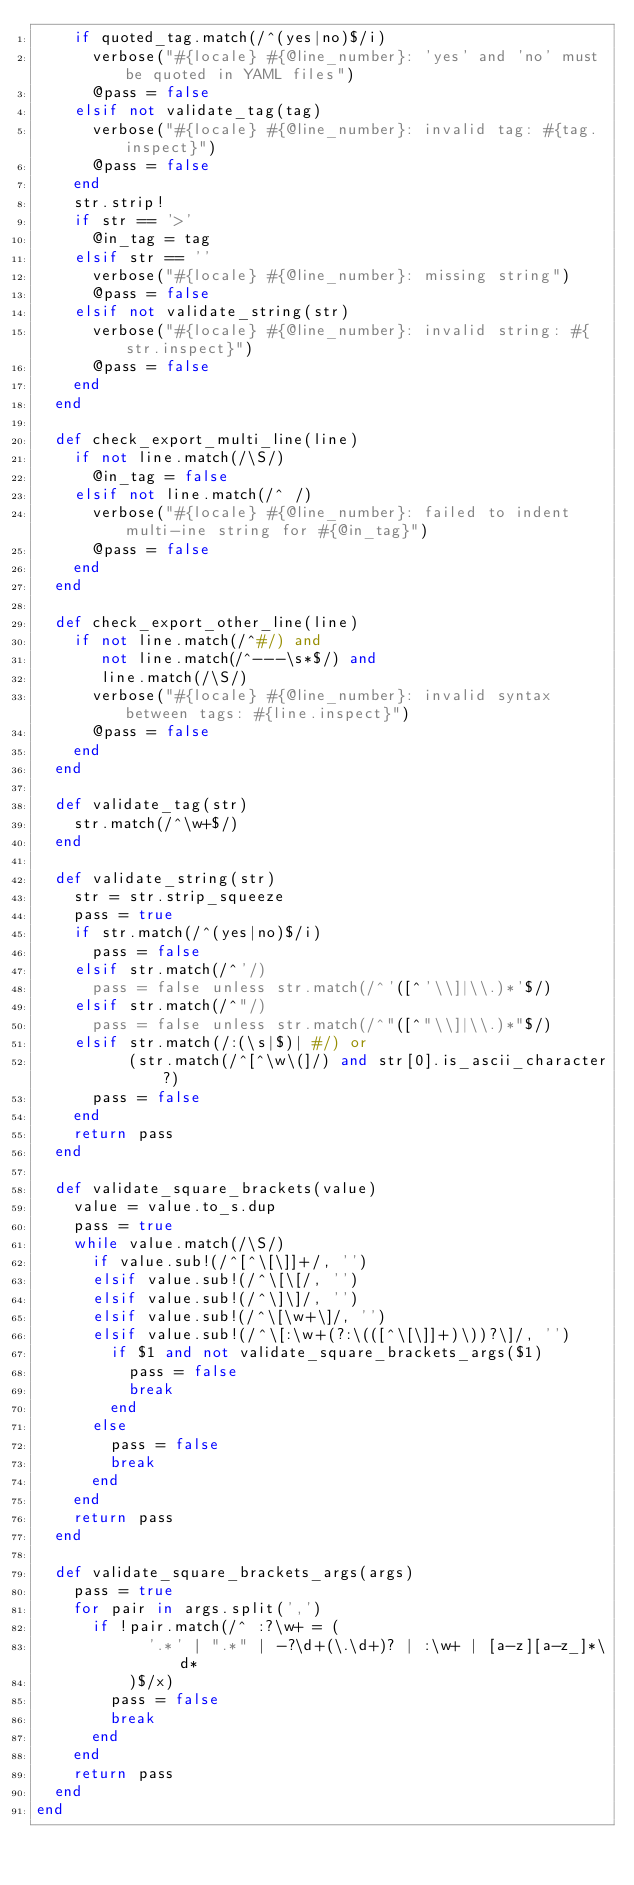<code> <loc_0><loc_0><loc_500><loc_500><_Ruby_>    if quoted_tag.match(/^(yes|no)$/i)
      verbose("#{locale} #{@line_number}: 'yes' and 'no' must be quoted in YAML files")
      @pass = false
    elsif not validate_tag(tag)
      verbose("#{locale} #{@line_number}: invalid tag: #{tag.inspect}")
      @pass = false
    end
    str.strip!
    if str == '>'
      @in_tag = tag
    elsif str == ''
      verbose("#{locale} #{@line_number}: missing string")
      @pass = false
    elsif not validate_string(str)
      verbose("#{locale} #{@line_number}: invalid string: #{str.inspect}")
      @pass = false
    end
  end

  def check_export_multi_line(line)
    if not line.match(/\S/)
      @in_tag = false
    elsif not line.match(/^ /)
      verbose("#{locale} #{@line_number}: failed to indent multi-ine string for #{@in_tag}")
      @pass = false
    end
  end

  def check_export_other_line(line)
    if not line.match(/^#/) and
       not line.match(/^---\s*$/) and
       line.match(/\S/)
      verbose("#{locale} #{@line_number}: invalid syntax between tags: #{line.inspect}")
      @pass = false
    end
  end

  def validate_tag(str)
    str.match(/^\w+$/)
  end

  def validate_string(str)
    str = str.strip_squeeze
    pass = true
    if str.match(/^(yes|no)$/i)
      pass = false
    elsif str.match(/^'/)
      pass = false unless str.match(/^'([^'\\]|\\.)*'$/)
    elsif str.match(/^"/)
      pass = false unless str.match(/^"([^"\\]|\\.)*"$/)
    elsif str.match(/:(\s|$)| #/) or
          (str.match(/^[^\w\(]/) and str[0].is_ascii_character?)
      pass = false
    end
    return pass
  end

  def validate_square_brackets(value)
    value = value.to_s.dup
    pass = true
    while value.match(/\S/)
      if value.sub!(/^[^\[\]]+/, '')
      elsif value.sub!(/^\[\[/, '')
      elsif value.sub!(/^\]\]/, '')
      elsif value.sub!(/^\[\w+\]/, '')
      elsif value.sub!(/^\[:\w+(?:\(([^\[\]]+)\))?\]/, '')
        if $1 and not validate_square_brackets_args($1)
          pass = false
          break
        end
      else
        pass = false
        break
      end
    end
    return pass
  end

  def validate_square_brackets_args(args)
    pass = true
    for pair in args.split(',')
      if !pair.match(/^ :?\w+ = (
            '.*' | ".*" | -?\d+(\.\d+)? | :\w+ | [a-z][a-z_]*\d*
          )$/x)
        pass = false
        break
      end
    end
    return pass
  end
end
</code> 